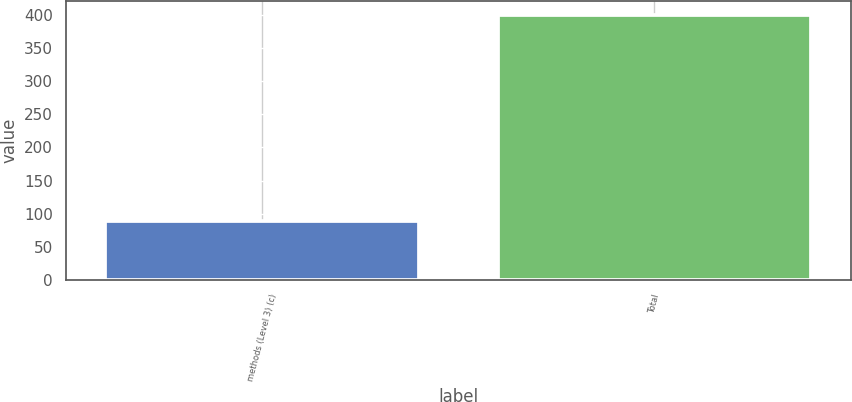Convert chart to OTSL. <chart><loc_0><loc_0><loc_500><loc_500><bar_chart><fcel>methods (Level 3) (c)<fcel>Total<nl><fcel>89<fcel>400<nl></chart> 